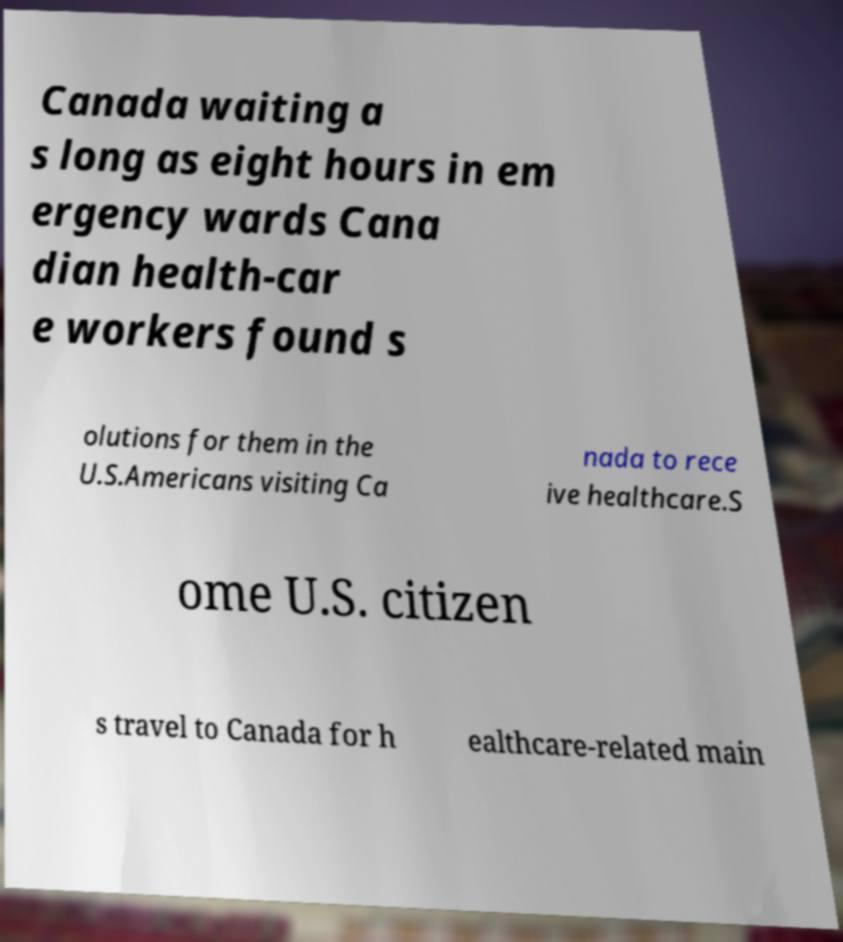Could you assist in decoding the text presented in this image and type it out clearly? Canada waiting a s long as eight hours in em ergency wards Cana dian health-car e workers found s olutions for them in the U.S.Americans visiting Ca nada to rece ive healthcare.S ome U.S. citizen s travel to Canada for h ealthcare-related main 